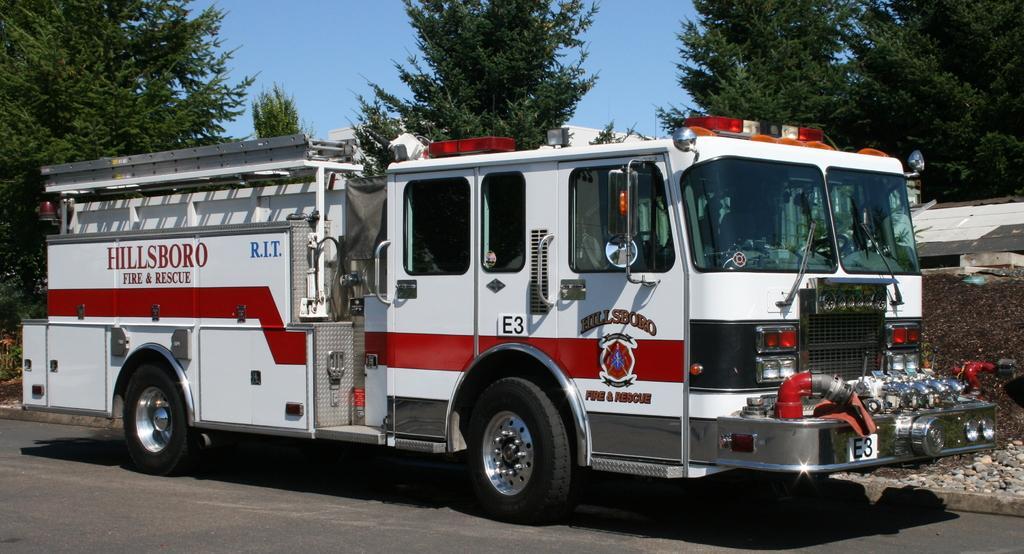Describe this image in one or two sentences. Here I can see a vehicle on the road. On the right side there is a wall. In the background there are some trees. At the top, I can see the sky. 